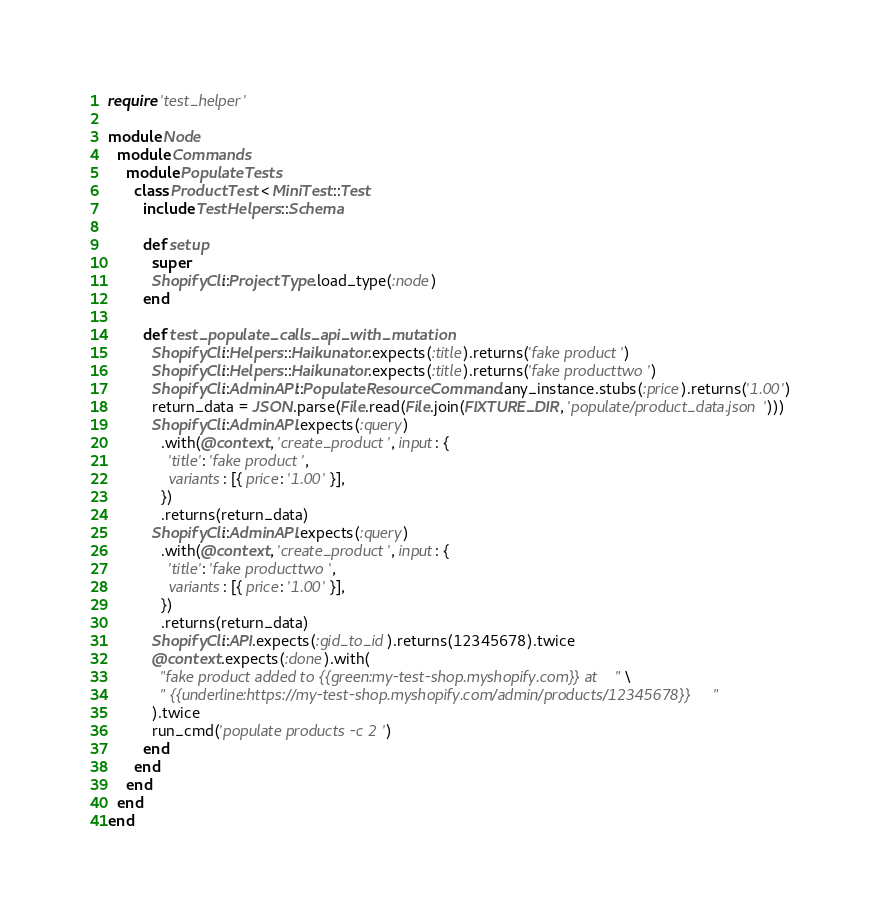Convert code to text. <code><loc_0><loc_0><loc_500><loc_500><_Ruby_>require 'test_helper'

module Node
  module Commands
    module PopulateTests
      class ProductTest < MiniTest::Test
        include TestHelpers::Schema

        def setup
          super
          ShopifyCli::ProjectType.load_type(:node)
        end

        def test_populate_calls_api_with_mutation
          ShopifyCli::Helpers::Haikunator.expects(:title).returns('fake product')
          ShopifyCli::Helpers::Haikunator.expects(:title).returns('fake producttwo')
          ShopifyCli::AdminAPI::PopulateResourceCommand.any_instance.stubs(:price).returns('1.00')
          return_data = JSON.parse(File.read(File.join(FIXTURE_DIR, 'populate/product_data.json')))
          ShopifyCli::AdminAPI.expects(:query)
            .with(@context, 'create_product', input: {
              'title': 'fake product',
              variants: [{ price: '1.00' }],
            })
            .returns(return_data)
          ShopifyCli::AdminAPI.expects(:query)
            .with(@context, 'create_product', input: {
              'title': 'fake producttwo',
              variants: [{ price: '1.00' }],
            })
            .returns(return_data)
          ShopifyCli::API.expects(:gid_to_id).returns(12345678).twice
          @context.expects(:done).with(
            "fake product added to {{green:my-test-shop.myshopify.com}} at" \
            " {{underline:https://my-test-shop.myshopify.com/admin/products/12345678}}"
          ).twice
          run_cmd('populate products -c 2')
        end
      end
    end
  end
end
</code> 